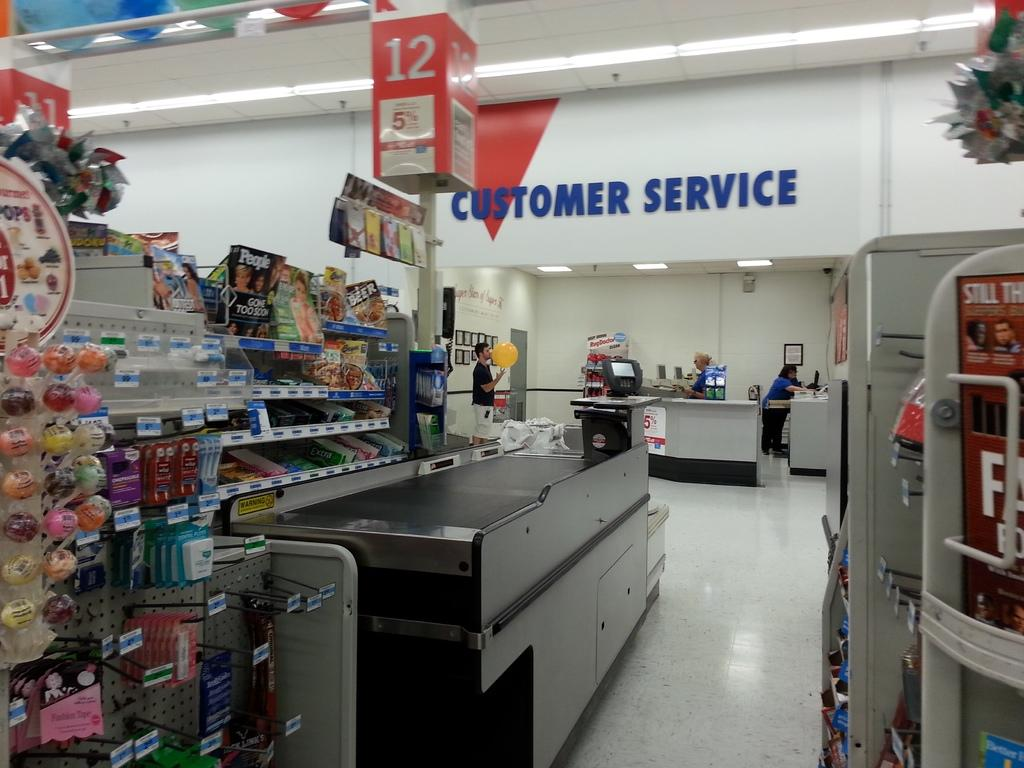<image>
Describe the image concisely. Store with the Customer Service section in the back. 